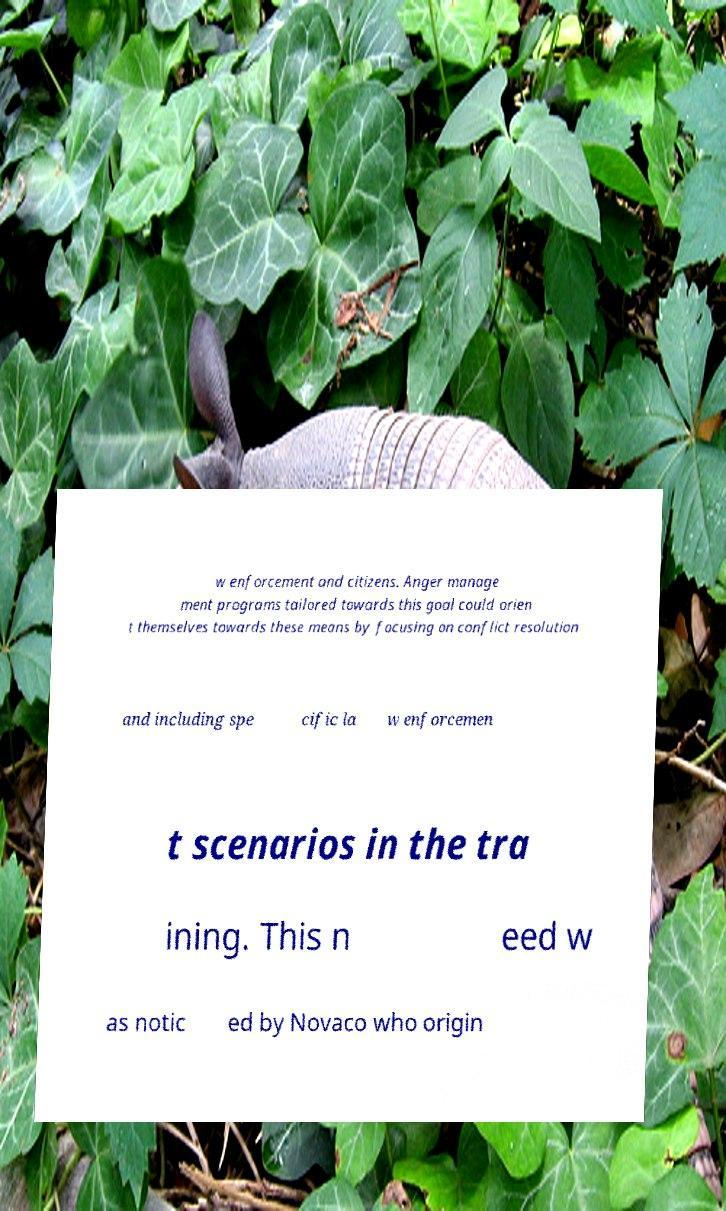Please read and relay the text visible in this image. What does it say? w enforcement and citizens. Anger manage ment programs tailored towards this goal could orien t themselves towards these means by focusing on conflict resolution and including spe cific la w enforcemen t scenarios in the tra ining. This n eed w as notic ed by Novaco who origin 